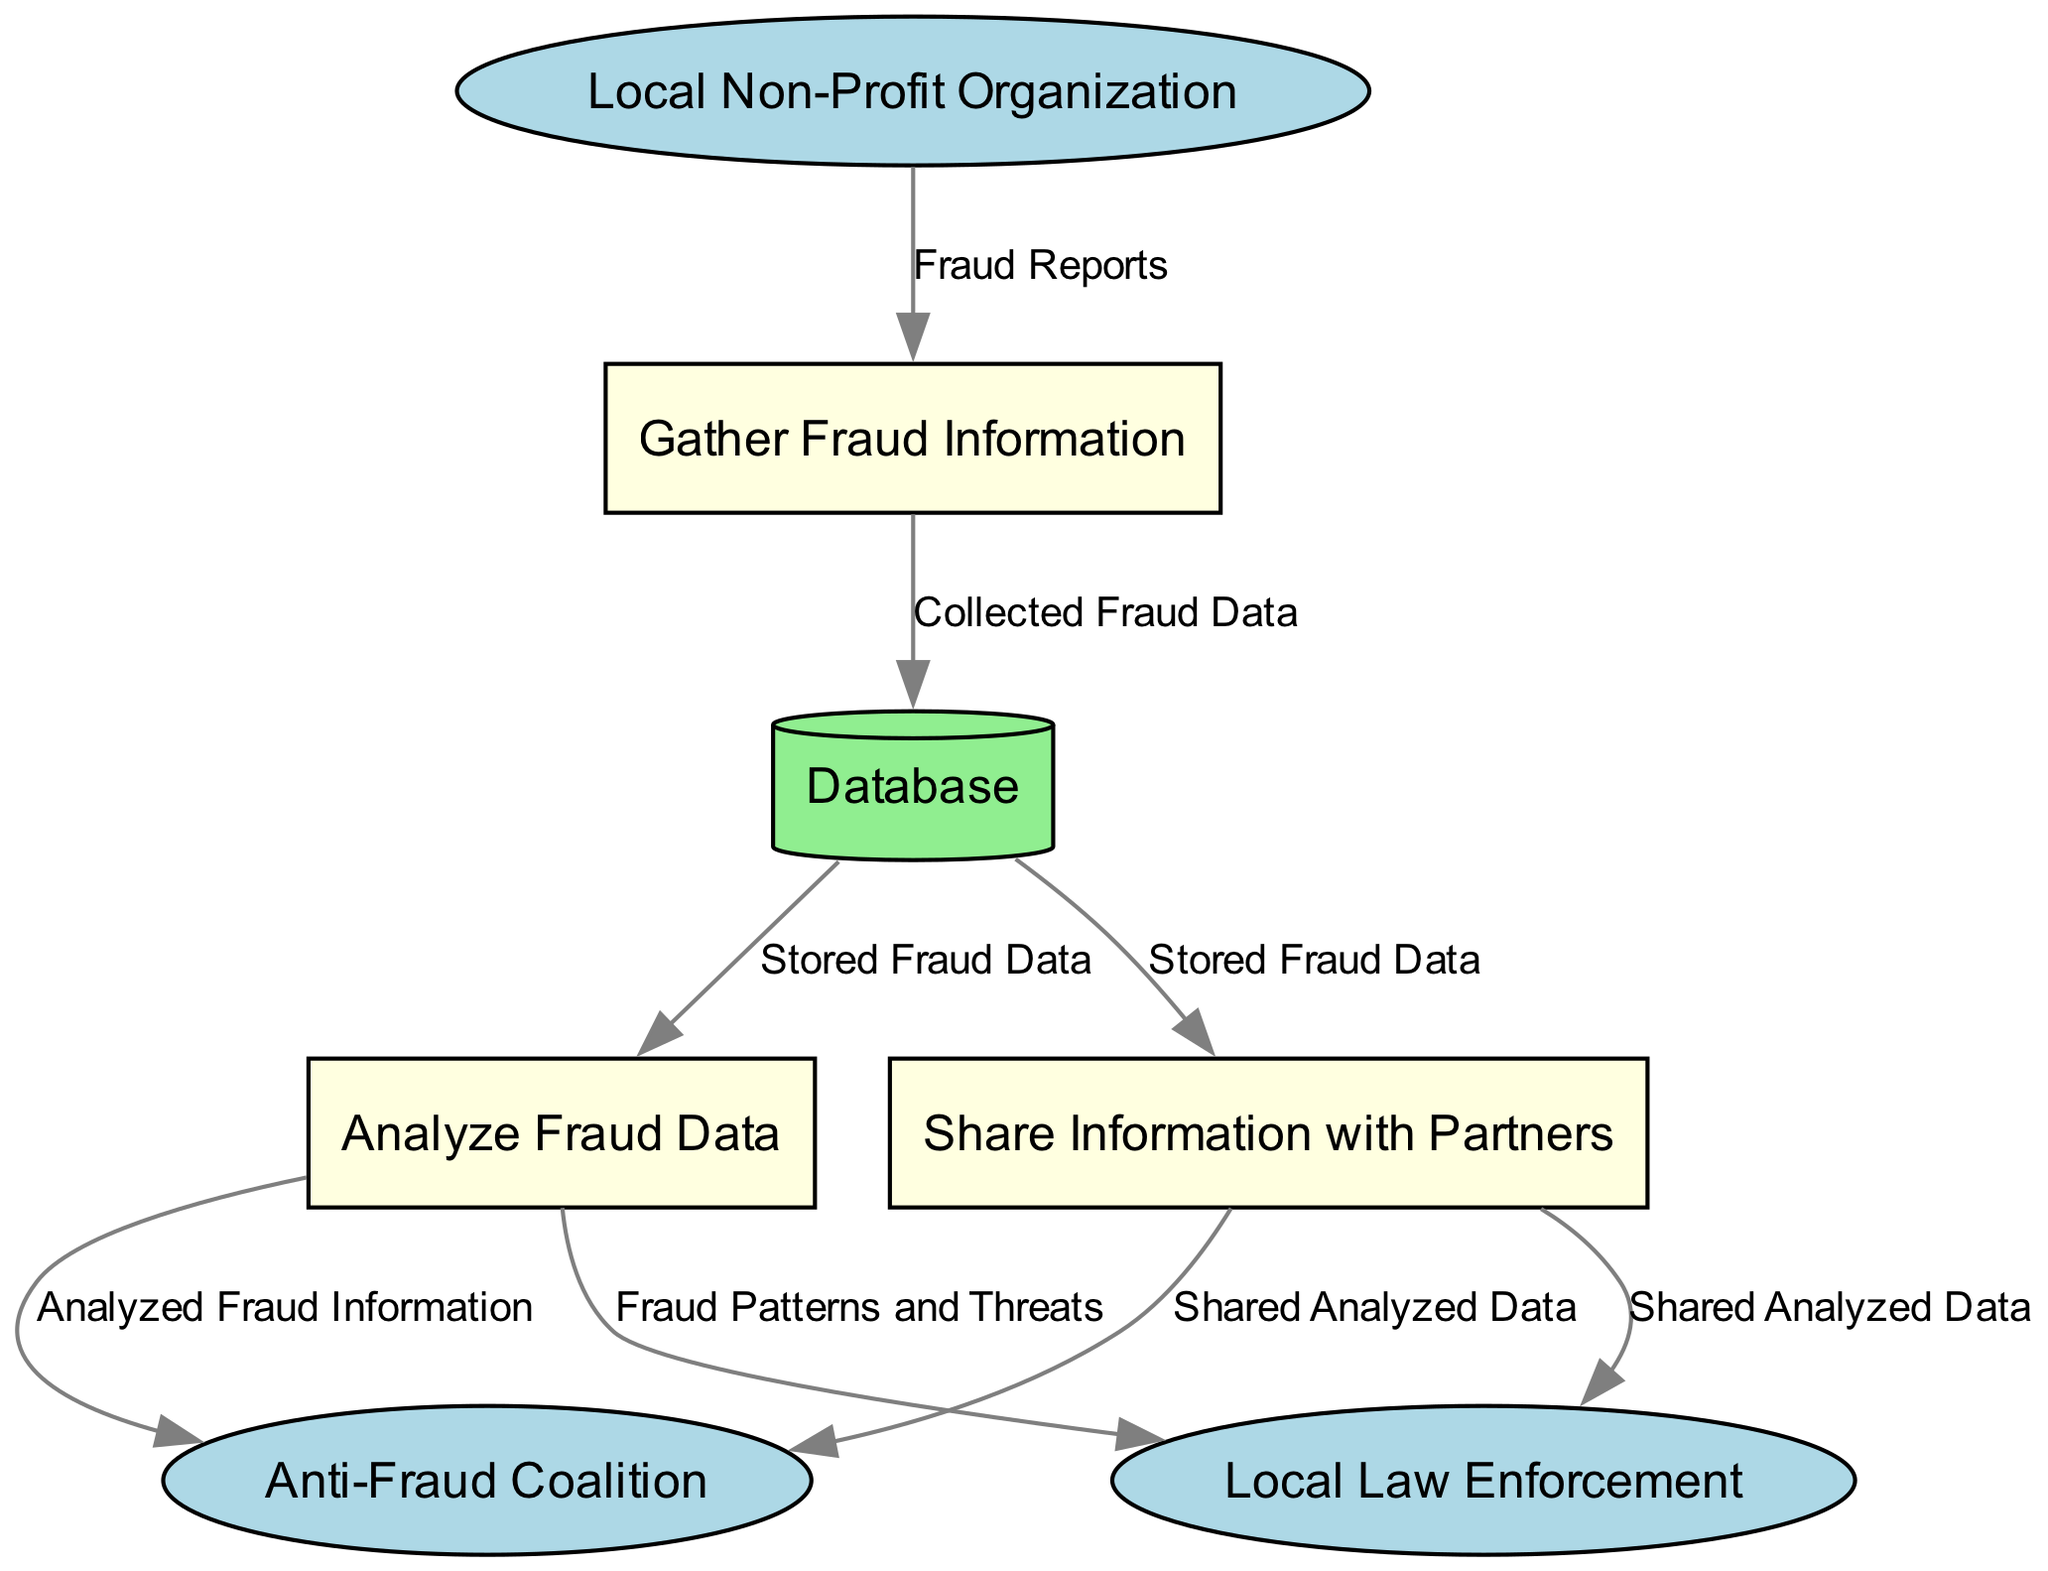What is the initial source of data in this diagram? The initial source of data in the diagram is the "Local Non-Profit Organization," which provides "Fraud Reports" to the "Gather Fraud Information" process.
Answer: Local Non-Profit Organization How many external entities are present in the diagram? There are three external entities in the diagram: the "Local Non-Profit Organization," "Anti-Fraud Coalition," and "Local Law Enforcement."
Answer: 3 What is stored in the Database? The "Database" stores "Collected Fraud Data," which includes all the information gathered from reports before further analysis.
Answer: Collected Fraud Data Which process analyzes the stored fraud data? The "Analyze Fraud Data" process is responsible for analyzing the stored fraud data to identify patterns and threats.
Answer: Analyze Fraud Data Who receives the analyzed fraud information? The "Anti-Fraud Coalition" and "Local Law Enforcement" each receive the "Analyzed Fraud Information" from the "Analyze Fraud Data" process.
Answer: Anti-Fraud Coalition, Local Law Enforcement What data does the "Share Information with Partners" process output? The "Share Information with Partners" process outputs "Shared Analyzed Data" to both the "Anti-Fraud Coalition" and "Local Law Enforcement."
Answer: Shared Analyzed Data What type of data is shared with partners? The shared data with partners consists of "Shared Analyzed Data," which has been previously processed and analyzed for relevance to both organizations' missions.
Answer: Shared Analyzed Data Which process feeds data into the Database after gathering it? The "Gather Fraud Information" process collects data and feeds it into the "Database" as "Collected Fraud Data."
Answer: Gather Fraud Information In total, how many processes are depicted in the diagram? There are three processes depicted in the diagram: "Gather Fraud Information," "Analyze Fraud Data," and "Share Information with Partners."
Answer: 3 